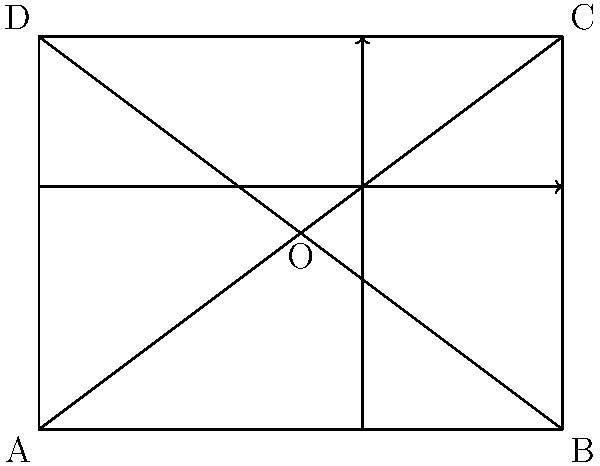In the composition of dramatic scenes in animated films, the Rule of Thirds is often complemented by the Golden Ratio. Given the frame ABCD, where point O represents the center, at what relative position along the width of the frame would you place a key element to adhere to the Golden Ratio principle, and how does this compare to the Rule of Thirds? To answer this question, we need to follow these steps:

1. Recall the Golden Ratio: The Golden Ratio, often denoted by φ (phi), is approximately 1.618033988749895.

2. Calculate the Golden Ratio position:
   - In a composition, the Golden Ratio point is located at approximately 61.8% of the distance from either edge.
   - This can be calculated as: $1 / φ ≈ 0.618$ or 61.8%

3. Compare with the Rule of Thirds:
   - The Rule of Thirds divides the frame into a 3x3 grid.
   - The key elements are placed at the intersection points or along these lines.
   - These points are located at 1/3 and 2/3 of the frame's width and height.

4. Analyze the difference:
   - Golden Ratio point: 61.8% from the left (or 38.2% from the right)
   - Rule of Thirds point: 66.7% from the left (or 33.3% from the right)

5. Interpret the result:
   - The Golden Ratio point is slightly closer to the center compared to the Rule of Thirds.
   - This creates a more subtle and often more aesthetically pleasing composition.

In the diagram, the vertical line represents the Golden Ratio position along the width of the frame, while the horizontal line shows the same principle applied to the height.
Answer: 61.8% from the left edge; slightly closer to center than Rule of Thirds (66.7%). 